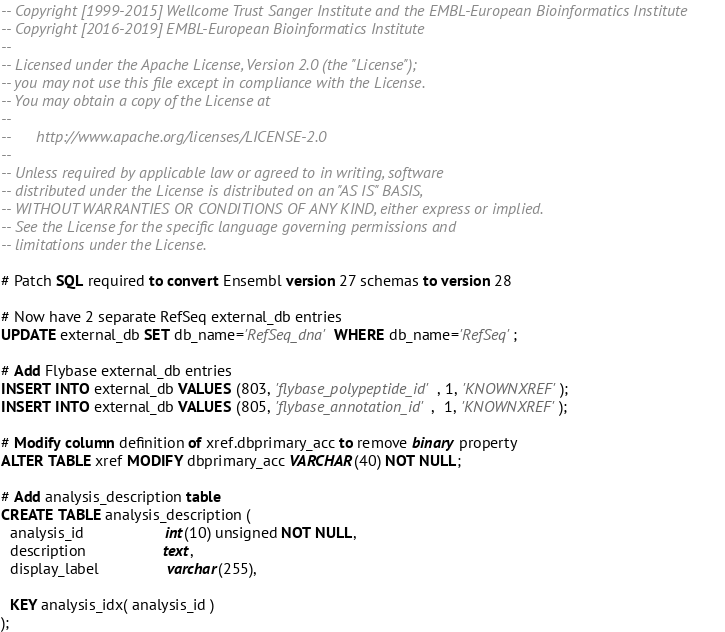<code> <loc_0><loc_0><loc_500><loc_500><_SQL_>-- Copyright [1999-2015] Wellcome Trust Sanger Institute and the EMBL-European Bioinformatics Institute
-- Copyright [2016-2019] EMBL-European Bioinformatics Institute
-- 
-- Licensed under the Apache License, Version 2.0 (the "License");
-- you may not use this file except in compliance with the License.
-- You may obtain a copy of the License at
-- 
--      http://www.apache.org/licenses/LICENSE-2.0
-- 
-- Unless required by applicable law or agreed to in writing, software
-- distributed under the License is distributed on an "AS IS" BASIS,
-- WITHOUT WARRANTIES OR CONDITIONS OF ANY KIND, either express or implied.
-- See the License for the specific language governing permissions and
-- limitations under the License.

# Patch SQL required to convert Ensembl version 27 schemas to version 28

# Now have 2 separate RefSeq external_db entries
UPDATE external_db SET db_name='RefSeq_dna' WHERE db_name='RefSeq';

# Add Flybase external_db entries
INSERT INTO external_db VALUES (803, 'flybase_polypeptide_id', 1, 'KNOWNXREF');
INSERT INTO external_db VALUES (805, 'flybase_annotation_id',  1, 'KNOWNXREF');

# Modify column definition of xref.dbprimary_acc to remove binary property
ALTER TABLE xref MODIFY dbprimary_acc VARCHAR(40) NOT NULL;

# Add analysis_description table
CREATE TABLE analysis_description (
  analysis_id	               int(10) unsigned NOT NULL,
  description                  text,
  display_label                varchar(255),

  KEY analysis_idx( analysis_id )
);
</code> 